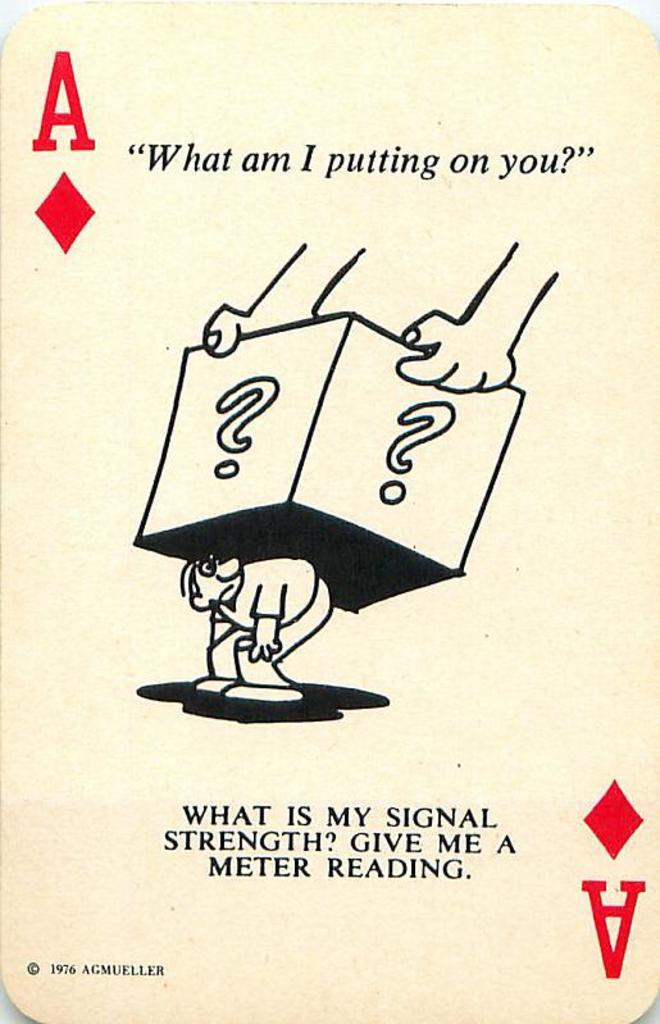What question is being asked on the card?
Give a very brief answer. What am i putting on you?. 